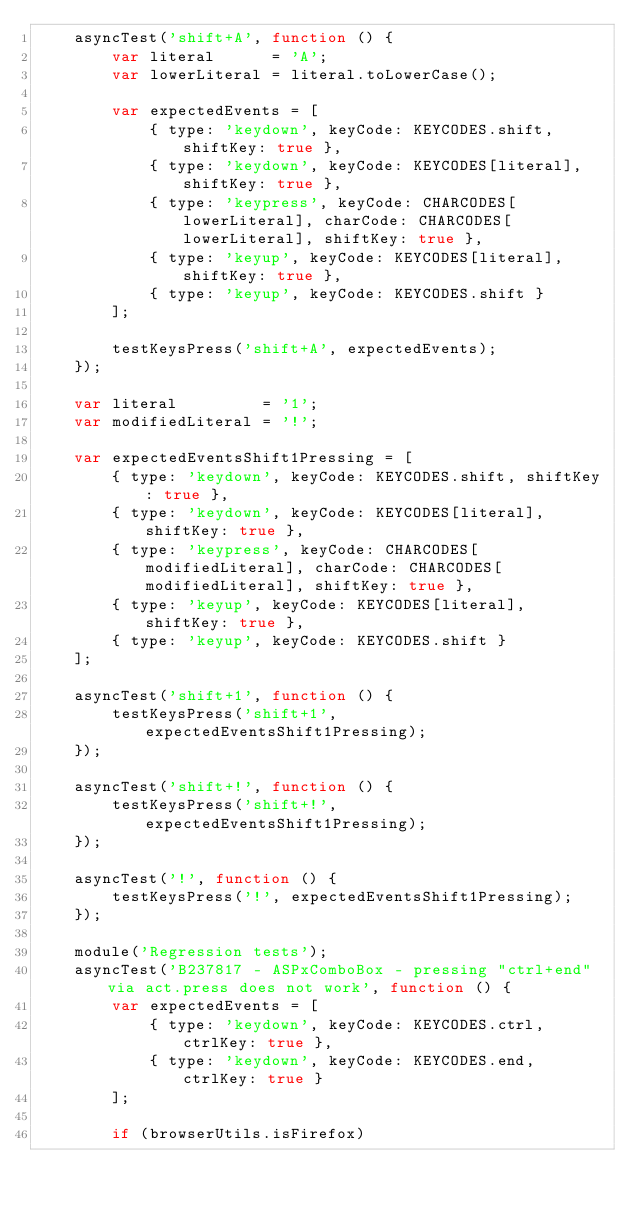<code> <loc_0><loc_0><loc_500><loc_500><_JavaScript_>    asyncTest('shift+A', function () {
        var literal      = 'A';
        var lowerLiteral = literal.toLowerCase();

        var expectedEvents = [
            { type: 'keydown', keyCode: KEYCODES.shift, shiftKey: true },
            { type: 'keydown', keyCode: KEYCODES[literal], shiftKey: true },
            { type: 'keypress', keyCode: CHARCODES[lowerLiteral], charCode: CHARCODES[lowerLiteral], shiftKey: true },
            { type: 'keyup', keyCode: KEYCODES[literal], shiftKey: true },
            { type: 'keyup', keyCode: KEYCODES.shift }
        ];

        testKeysPress('shift+A', expectedEvents);
    });

    var literal         = '1';
    var modifiedLiteral = '!';

    var expectedEventsShift1Pressing = [
        { type: 'keydown', keyCode: KEYCODES.shift, shiftKey: true },
        { type: 'keydown', keyCode: KEYCODES[literal], shiftKey: true },
        { type: 'keypress', keyCode: CHARCODES[modifiedLiteral], charCode: CHARCODES[modifiedLiteral], shiftKey: true },
        { type: 'keyup', keyCode: KEYCODES[literal], shiftKey: true },
        { type: 'keyup', keyCode: KEYCODES.shift }
    ];

    asyncTest('shift+1', function () {
        testKeysPress('shift+1', expectedEventsShift1Pressing);
    });

    asyncTest('shift+!', function () {
        testKeysPress('shift+!', expectedEventsShift1Pressing);
    });

    asyncTest('!', function () {
        testKeysPress('!', expectedEventsShift1Pressing);
    });

    module('Regression tests');
    asyncTest('B237817 - ASPxComboBox - pressing "ctrl+end" via act.press does not work', function () {
        var expectedEvents = [
            { type: 'keydown', keyCode: KEYCODES.ctrl, ctrlKey: true },
            { type: 'keydown', keyCode: KEYCODES.end, ctrlKey: true }
        ];

        if (browserUtils.isFirefox)</code> 